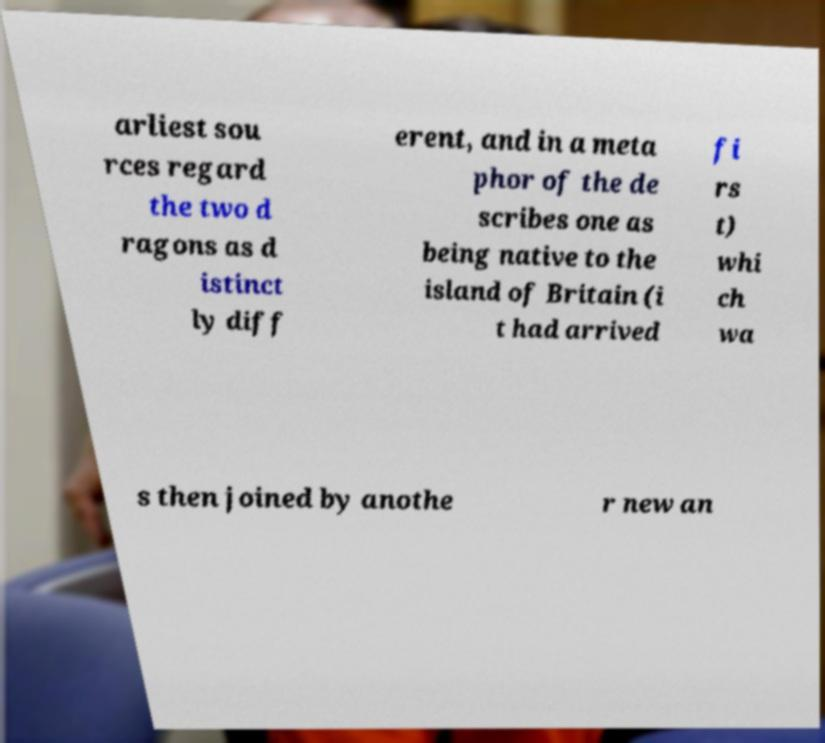Could you extract and type out the text from this image? arliest sou rces regard the two d ragons as d istinct ly diff erent, and in a meta phor of the de scribes one as being native to the island of Britain (i t had arrived fi rs t) whi ch wa s then joined by anothe r new an 